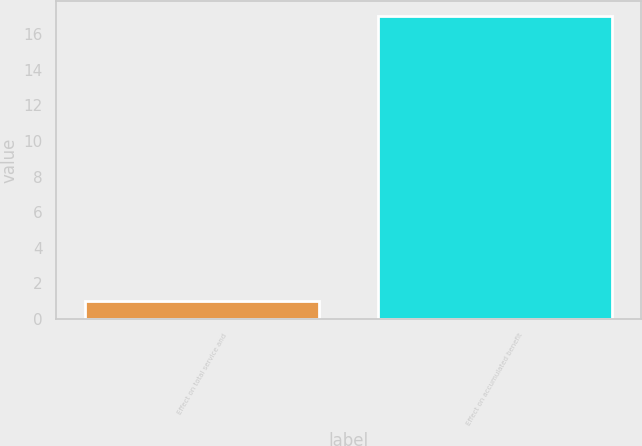Convert chart. <chart><loc_0><loc_0><loc_500><loc_500><bar_chart><fcel>Effect on total service and<fcel>Effect on accumulated benefit<nl><fcel>1<fcel>17<nl></chart> 